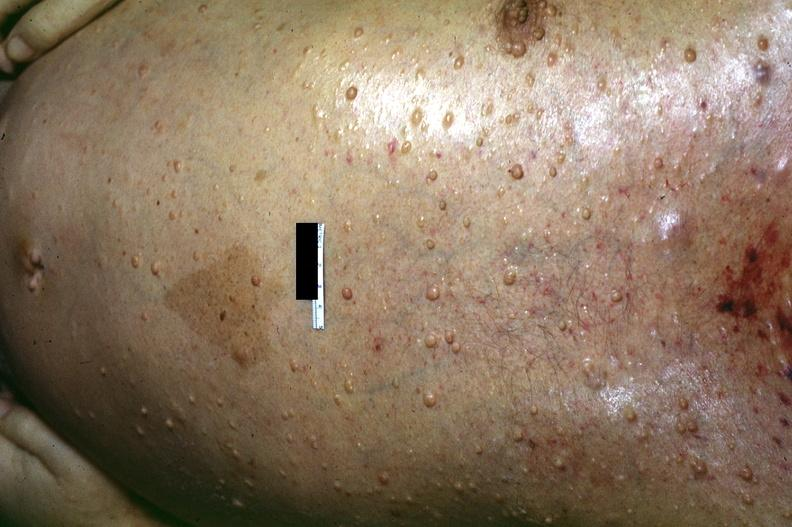does this image show skin, neurofibromatosis?
Answer the question using a single word or phrase. Yes 